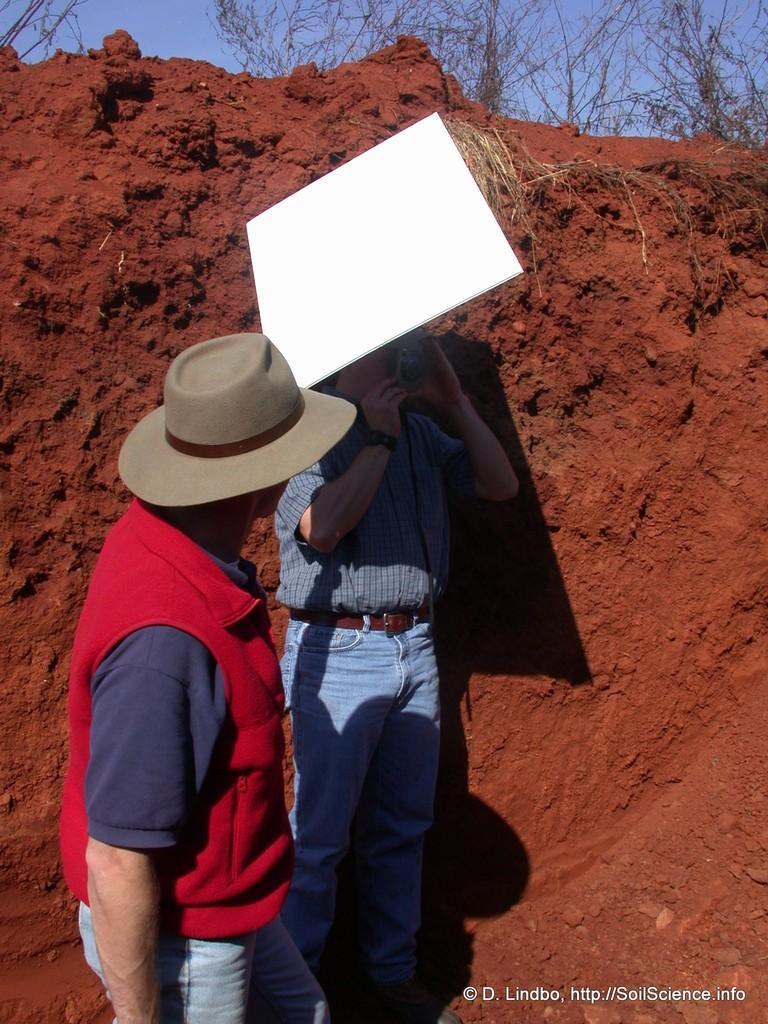How many people are in the image? There are two people in the image. What type of terrain is visible in the image? There is sand visible in the image. What can be seen in the background of the image? There are trees and sky visible in the background of the image. Where is the text located in the image? The text is on the right side of the image. What type of plastic ornament is hanging from the tree in the image? There is no plastic ornament hanging from the tree in the image; only trees and sky are visible in the background. Can you describe the bee that is buzzing around the people in the image? There are no bees present in the image; only two people, sand, trees, sky, and text are visible. 